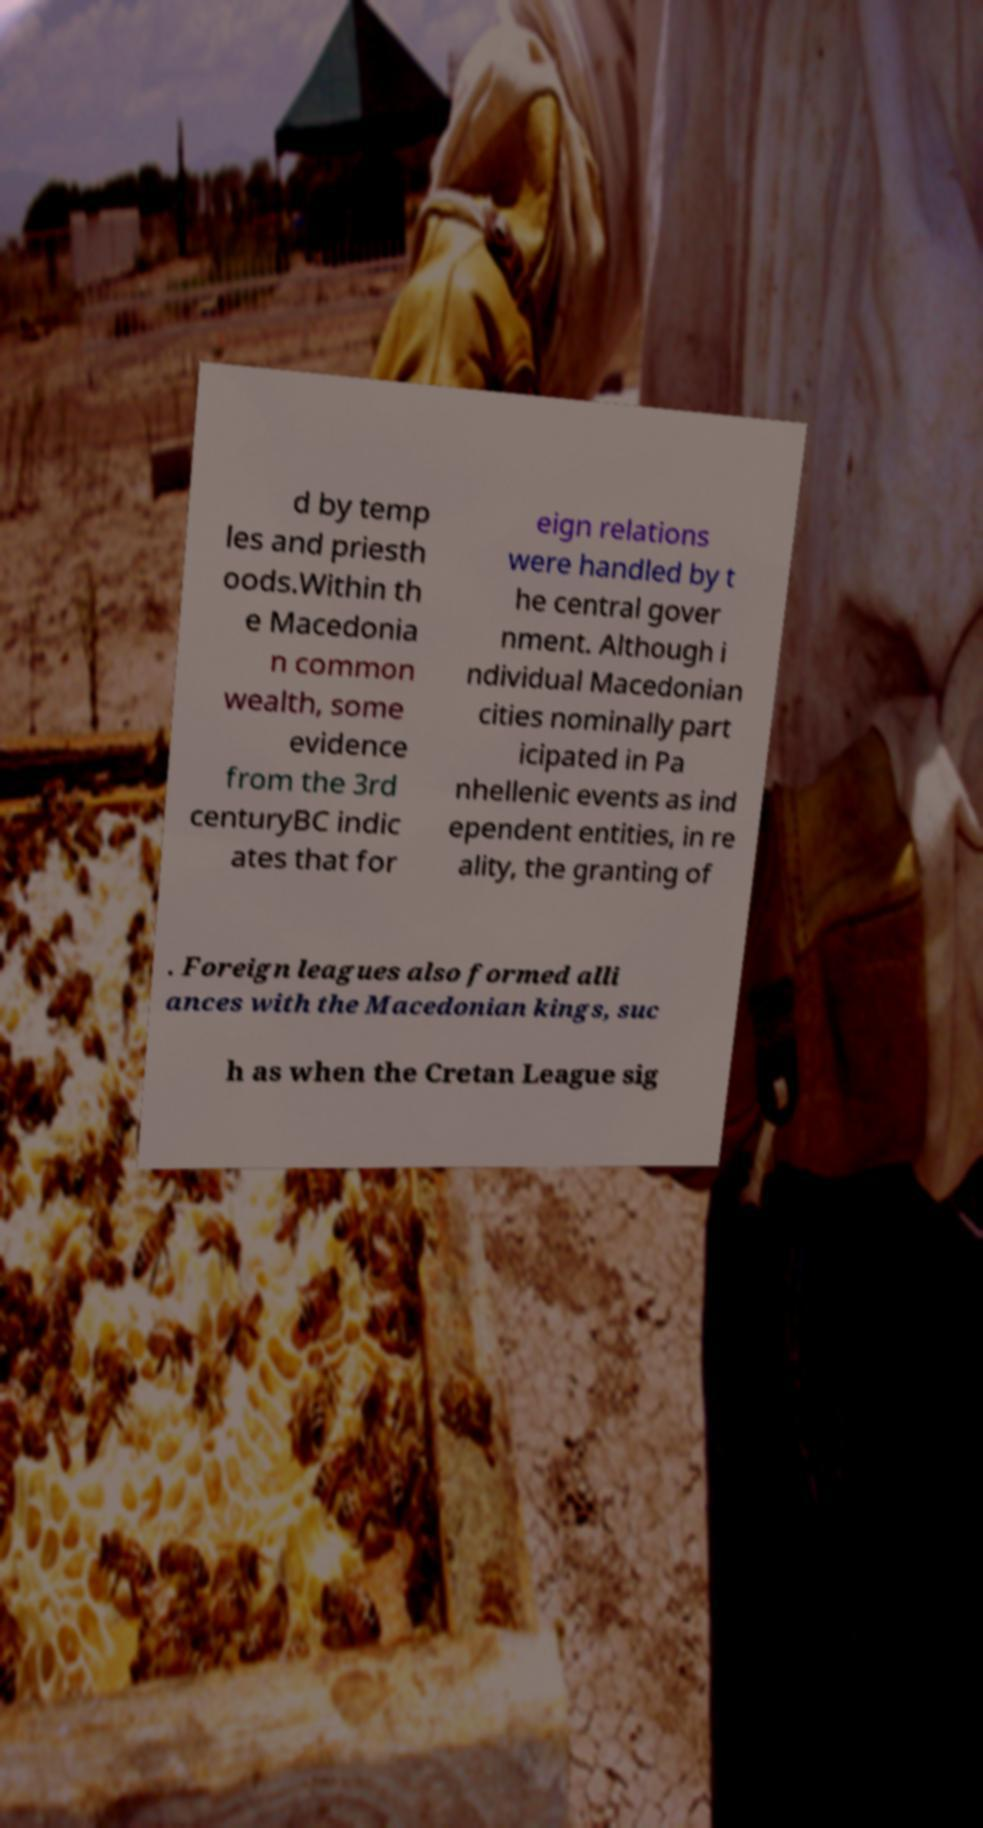For documentation purposes, I need the text within this image transcribed. Could you provide that? d by temp les and priesth oods.Within th e Macedonia n common wealth, some evidence from the 3rd centuryBC indic ates that for eign relations were handled by t he central gover nment. Although i ndividual Macedonian cities nominally part icipated in Pa nhellenic events as ind ependent entities, in re ality, the granting of . Foreign leagues also formed alli ances with the Macedonian kings, suc h as when the Cretan League sig 